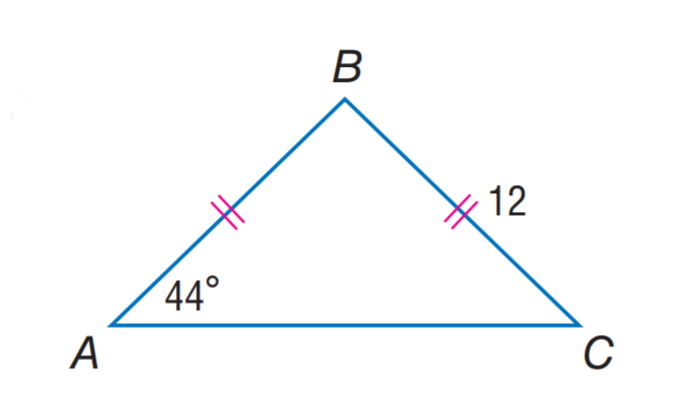Question: Find A B.
Choices:
A. 12
B. 16
C. 24
D. 44
Answer with the letter. Answer: A Question: Find m \angle B.
Choices:
A. 44
B. 89
C. 92
D. 98
Answer with the letter. Answer: C 